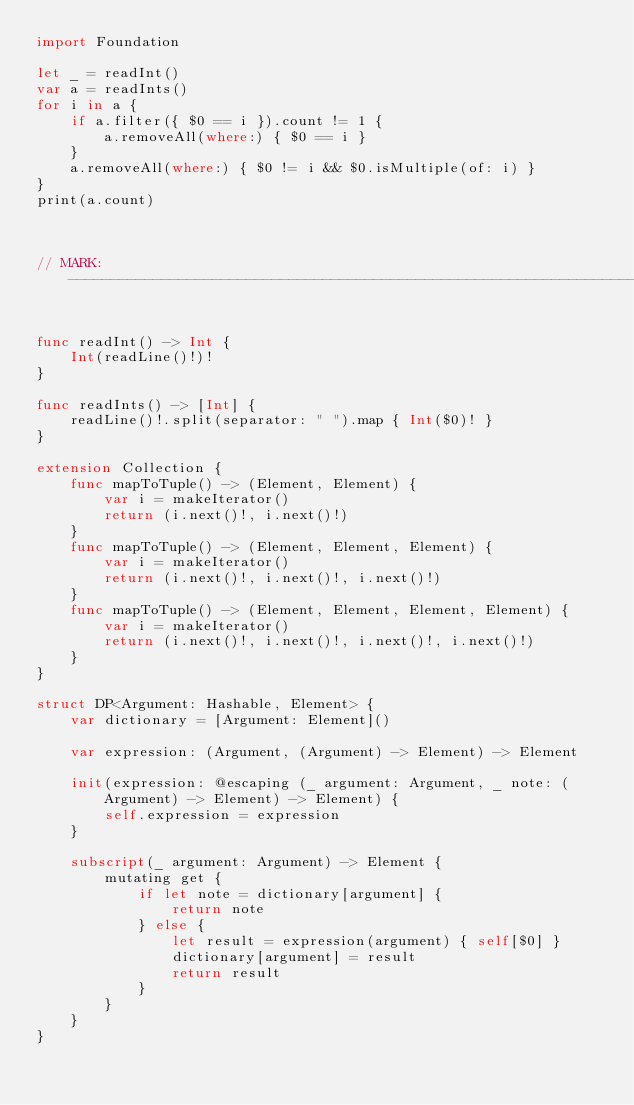<code> <loc_0><loc_0><loc_500><loc_500><_Swift_>import Foundation

let _ = readInt()
var a = readInts()
for i in a {
    if a.filter({ $0 == i }).count != 1 {
        a.removeAll(where:) { $0 == i }
    }
    a.removeAll(where:) { $0 != i && $0.isMultiple(of: i) }
}
print(a.count)



// MARK: -----------------------------------------------------------------------


func readInt() -> Int {
    Int(readLine()!)!
}

func readInts() -> [Int] {
    readLine()!.split(separator: " ").map { Int($0)! }
}

extension Collection {
    func mapToTuple() -> (Element, Element) {
        var i = makeIterator()
        return (i.next()!, i.next()!)
    }
    func mapToTuple() -> (Element, Element, Element) {
        var i = makeIterator()
        return (i.next()!, i.next()!, i.next()!)
    }
    func mapToTuple() -> (Element, Element, Element, Element) {
        var i = makeIterator()
        return (i.next()!, i.next()!, i.next()!, i.next()!)
    }
}

struct DP<Argument: Hashable, Element> {
    var dictionary = [Argument: Element]()
    
    var expression: (Argument, (Argument) -> Element) -> Element
    
    init(expression: @escaping (_ argument: Argument, _ note: (Argument) -> Element) -> Element) {
        self.expression = expression
    }
    
    subscript(_ argument: Argument) -> Element {
        mutating get {
            if let note = dictionary[argument] {
                return note
            } else {
                let result = expression(argument) { self[$0] }
                dictionary[argument] = result
                return result
            }
        }
    }
}
</code> 